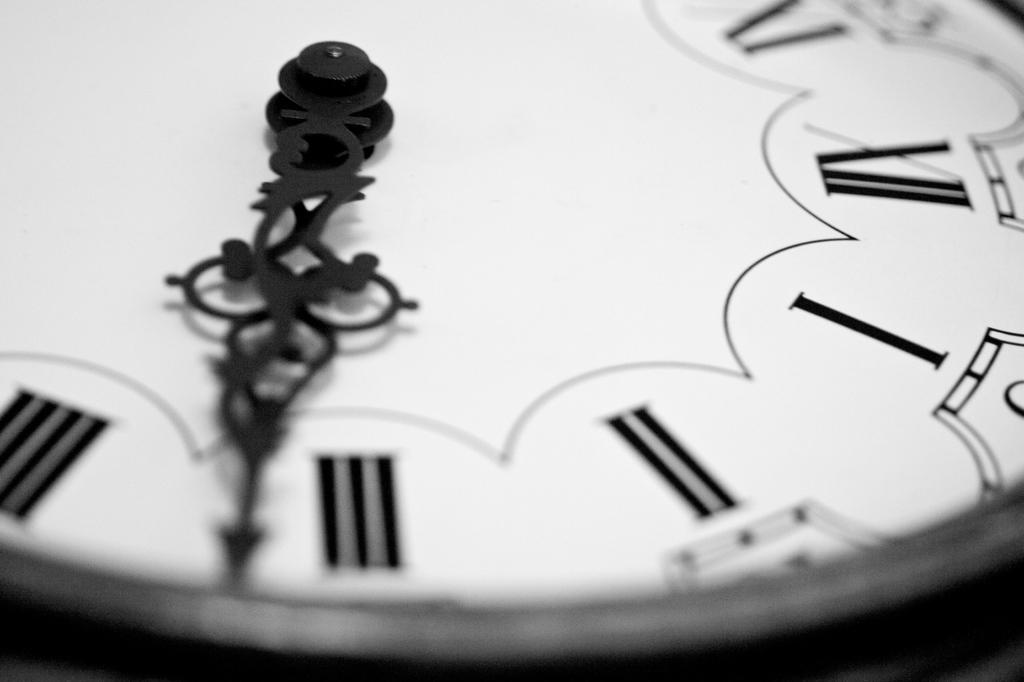What is the clock hand on?
Provide a short and direct response. 3. 